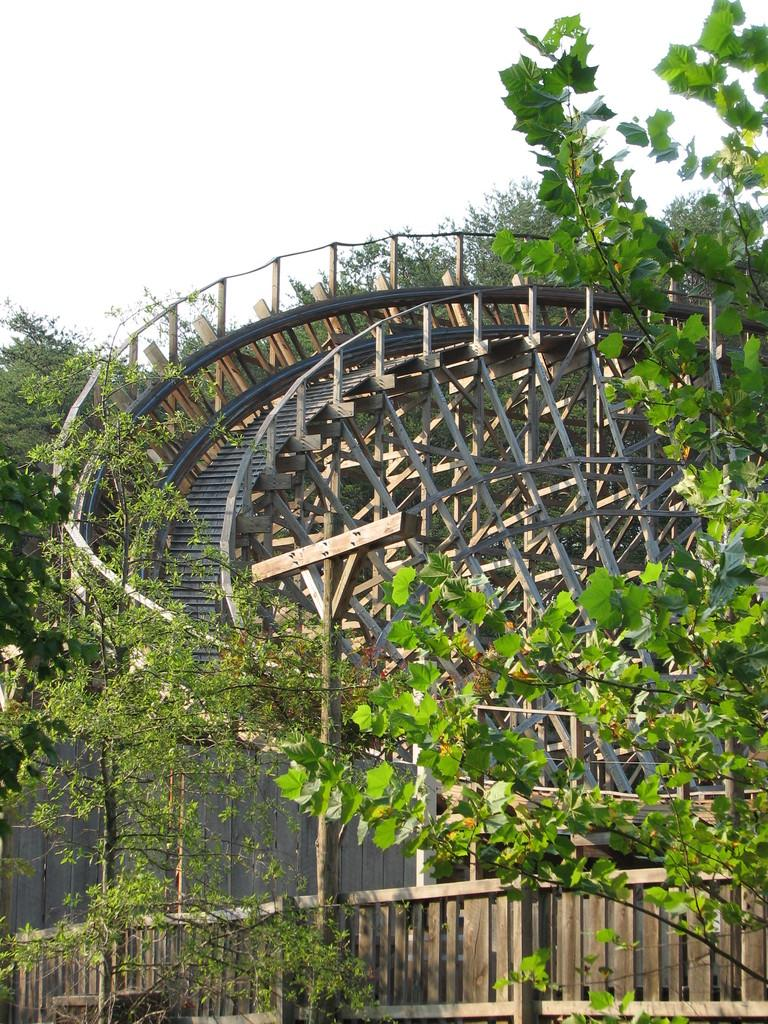What is the main feature of the image? There is a roller coaster track in the image. What can be seen in the background of the image? There are trees visible in the image. What type of barrier is present at the bottom of the image? There is a wooden fence at the bottom of the image. What type of note is attached to the roller coaster in the image? There is no note attached to the roller coaster in the image. What color is the coat worn by the tree in the image? There are no coats or trees wearing coats in the image. 